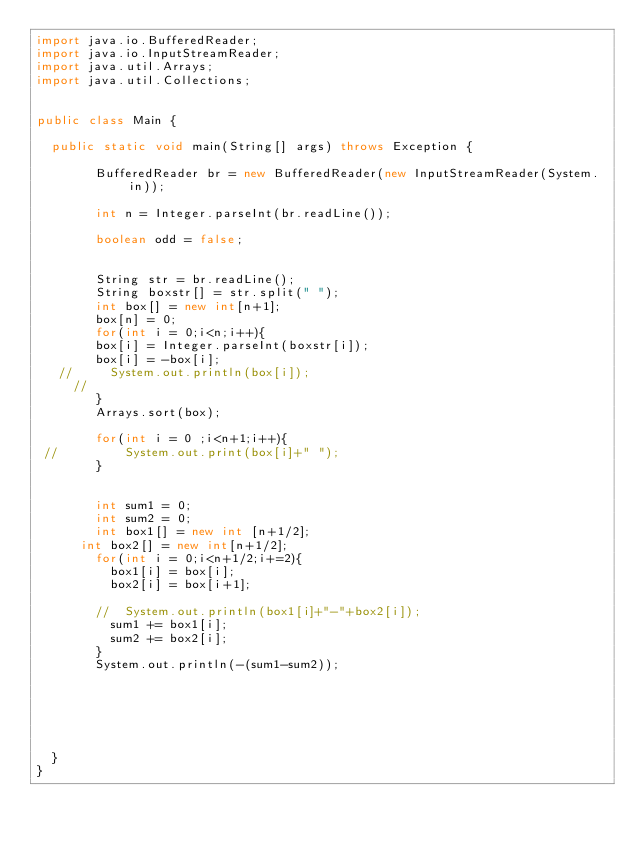<code> <loc_0><loc_0><loc_500><loc_500><_Java_>import java.io.BufferedReader;
import java.io.InputStreamReader;
import java.util.Arrays;
import java.util.Collections;


public class Main {
	
	public static void main(String[] args) throws Exception {
		
        BufferedReader br = new BufferedReader(new InputStreamReader(System.in));
        
        int n = Integer.parseInt(br.readLine()); 
        
        boolean odd = false;
        
        
        String str = br.readLine();
        String boxstr[] = str.split(" ");
        int box[] = new int[n+1];
        box[n] = 0;
        for(int i = 0;i<n;i++){
        box[i] = Integer.parseInt(boxstr[i]);
        box[i] = -box[i];
   //     System.out.println(box[i]);
     //   
        }
        Arrays.sort(box);
        
        for(int i = 0 ;i<n+1;i++){
 //       	System.out.print(box[i]+" ");
        }
        

        int sum1 = 0;
        int sum2 = 0;
        int box1[] = new int [n+1/2];
    	int box2[] = new int[n+1/2];
        for(int i = 0;i<n+1/2;i+=2){
        	box1[i] = box[i];
        	box2[i] = box[i+1];
        	
        //	System.out.println(box1[i]+"-"+box2[i]);
        	sum1 += box1[i];
        	sum2 += box2[i];
        }
        System.out.println(-(sum1-sum2));
        
        
        
        
        
        
	}
}</code> 